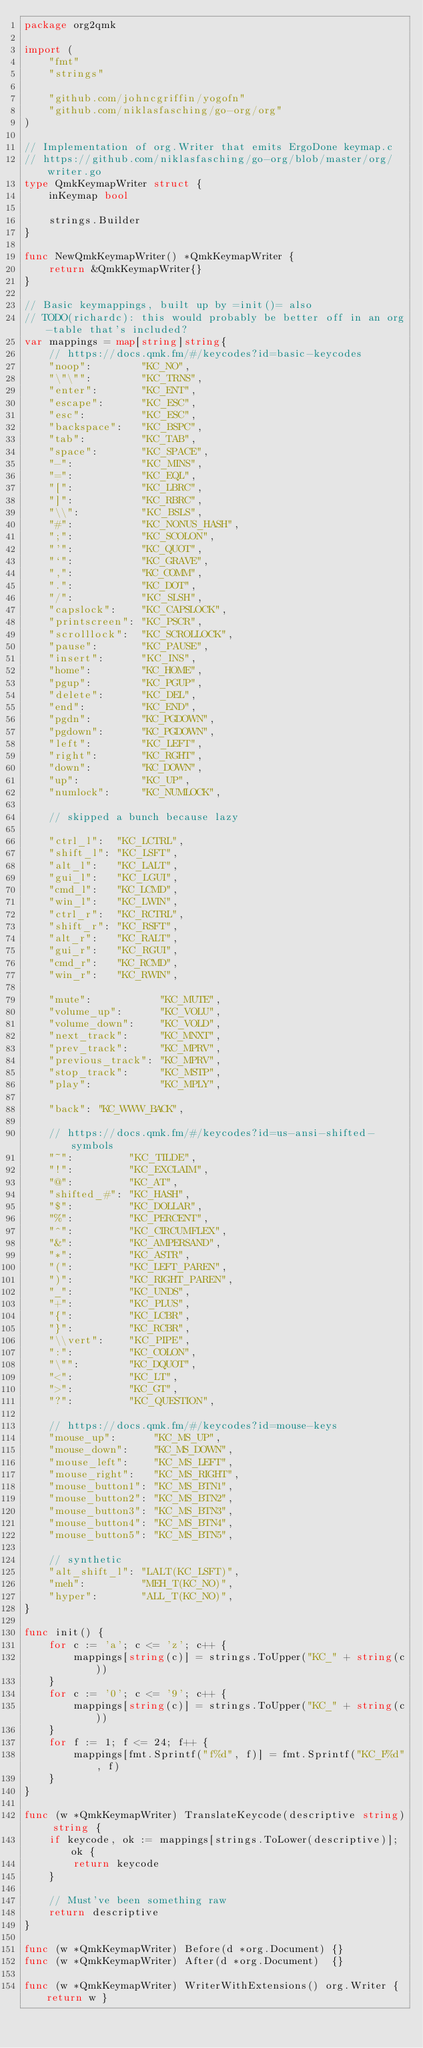Convert code to text. <code><loc_0><loc_0><loc_500><loc_500><_Go_>package org2qmk

import (
	"fmt"
	"strings"

	"github.com/johncgriffin/yogofn"
	"github.com/niklasfasching/go-org/org"
)

// Implementation of org.Writer that emits ErgoDone keymap.c
// https://github.com/niklasfasching/go-org/blob/master/org/writer.go
type QmkKeymapWriter struct {
	inKeymap bool

	strings.Builder
}

func NewQmkKeymapWriter() *QmkKeymapWriter {
	return &QmkKeymapWriter{}
}

// Basic keymappings, built up by =init()= also
// TODO(richardc): this would probably be better off in an org-table that's included?
var mappings = map[string]string{
	// https://docs.qmk.fm/#/keycodes?id=basic-keycodes
	"noop":        "KC_NO",
	"\"\"":        "KC_TRNS",
	"enter":       "KC_ENT",
	"escape":      "KC_ESC",
	"esc":         "KC_ESC",
	"backspace":   "KC_BSPC",
	"tab":         "KC_TAB",
	"space":       "KC_SPACE",
	"-":           "KC_MINS",
	"=":           "KC_EQL",
	"[":           "KC_LBRC",
	"]":           "KC_RBRC",
	"\\":          "KC_BSLS",
	"#":           "KC_NONUS_HASH",
	";":           "KC_SCOLON",
	"'":           "KC_QUOT",
	"`":           "KC_GRAVE",
	",":           "KC_COMM",
	".":           "KC_DOT",
	"/":           "KC_SLSH",
	"capslock":    "KC_CAPSLOCK",
	"printscreen": "KC_PSCR",
	"scrolllock":  "KC_SCROLLOCK",
	"pause":       "KC_PAUSE",
	"insert":      "KC_INS",
	"home":        "KC_HOME",
	"pgup":        "KC_PGUP",
	"delete":      "KC_DEL",
	"end":         "KC_END",
	"pgdn":        "KC_PGDOWN",
	"pgdown":      "KC_PGDOWN",
	"left":        "KC_LEFT",
	"right":       "KC_RGHT",
	"down":        "KC_DOWN",
	"up":          "KC_UP",
	"numlock":     "KC_NUMLOCK",

	// skipped a bunch because lazy

	"ctrl_l":  "KC_LCTRL",
	"shift_l": "KC_LSFT",
	"alt_l":   "KC_LALT",
	"gui_l":   "KC_LGUI",
	"cmd_l":   "KC_LCMD",
	"win_l":   "KC_LWIN",
	"ctrl_r":  "KC_RCTRL",
	"shift_r": "KC_RSFT",
	"alt_r":   "KC_RALT",
	"gui_r":   "KC_RGUI",
	"cmd_r":   "KC_RCMD",
	"win_r":   "KC_RWIN",

	"mute":           "KC_MUTE",
	"volume_up":      "KC_VOLU",
	"volume_down":    "KC_VOLD",
	"next_track":     "KC_MNXT",
	"prev_track":     "KC_MPRV",
	"previous_track": "KC_MPRV",
	"stop_track":     "KC_MSTP",
	"play":           "KC_MPLY",

	"back": "KC_WWW_BACK",

	// https://docs.qmk.fm/#/keycodes?id=us-ansi-shifted-symbols
	"~":         "KC_TILDE",
	"!":         "KC_EXCLAIM",
	"@":         "KC_AT",
	"shifted_#": "KC_HASH",
	"$":         "KC_DOLLAR",
	"%":         "KC_PERCENT",
	"^":         "KC_CIRCUMFLEX",
	"&":         "KC_AMPERSAND",
	"*":         "KC_ASTR",
	"(":         "KC_LEFT_PAREN",
	")":         "KC_RIGHT_PAREN",
	"_":         "KC_UNDS",
	"+":         "KC_PLUS",
	"{":         "KC_LCBR",
	"}":         "KC_RCBR",
	"\\vert":    "KC_PIPE",
	":":         "KC_COLON",
	"\"":        "KC_DQUOT",
	"<":         "KC_LT",
	">":         "KC_GT",
	"?":         "KC_QUESTION",

	// https://docs.qmk.fm/#/keycodes?id=mouse-keys
	"mouse_up":      "KC_MS_UP",
	"mouse_down":    "KC_MS_DOWN",
	"mouse_left":    "KC_MS_LEFT",
	"mouse_right":   "KC_MS_RIGHT",
	"mouse_button1": "KC_MS_BTN1",
	"mouse_button2": "KC_MS_BTN2",
	"mouse_button3": "KC_MS_BTN3",
	"mouse_button4": "KC_MS_BTN4",
	"mouse_button5": "KC_MS_BTN5",

	// synthetic
	"alt_shift_l": "LALT(KC_LSFT)",
	"meh":         "MEH_T(KC_NO)",
	"hyper":       "ALL_T(KC_NO)",
}

func init() {
	for c := 'a'; c <= 'z'; c++ {
		mappings[string(c)] = strings.ToUpper("KC_" + string(c))
	}
	for c := '0'; c <= '9'; c++ {
		mappings[string(c)] = strings.ToUpper("KC_" + string(c))
	}
	for f := 1; f <= 24; f++ {
		mappings[fmt.Sprintf("f%d", f)] = fmt.Sprintf("KC_F%d", f)
	}
}

func (w *QmkKeymapWriter) TranslateKeycode(descriptive string) string {
	if keycode, ok := mappings[strings.ToLower(descriptive)]; ok {
		return keycode
	}

	// Must've been something raw
	return descriptive
}

func (w *QmkKeymapWriter) Before(d *org.Document) {}
func (w *QmkKeymapWriter) After(d *org.Document)  {}

func (w *QmkKeymapWriter) WriterWithExtensions() org.Writer { return w }
</code> 